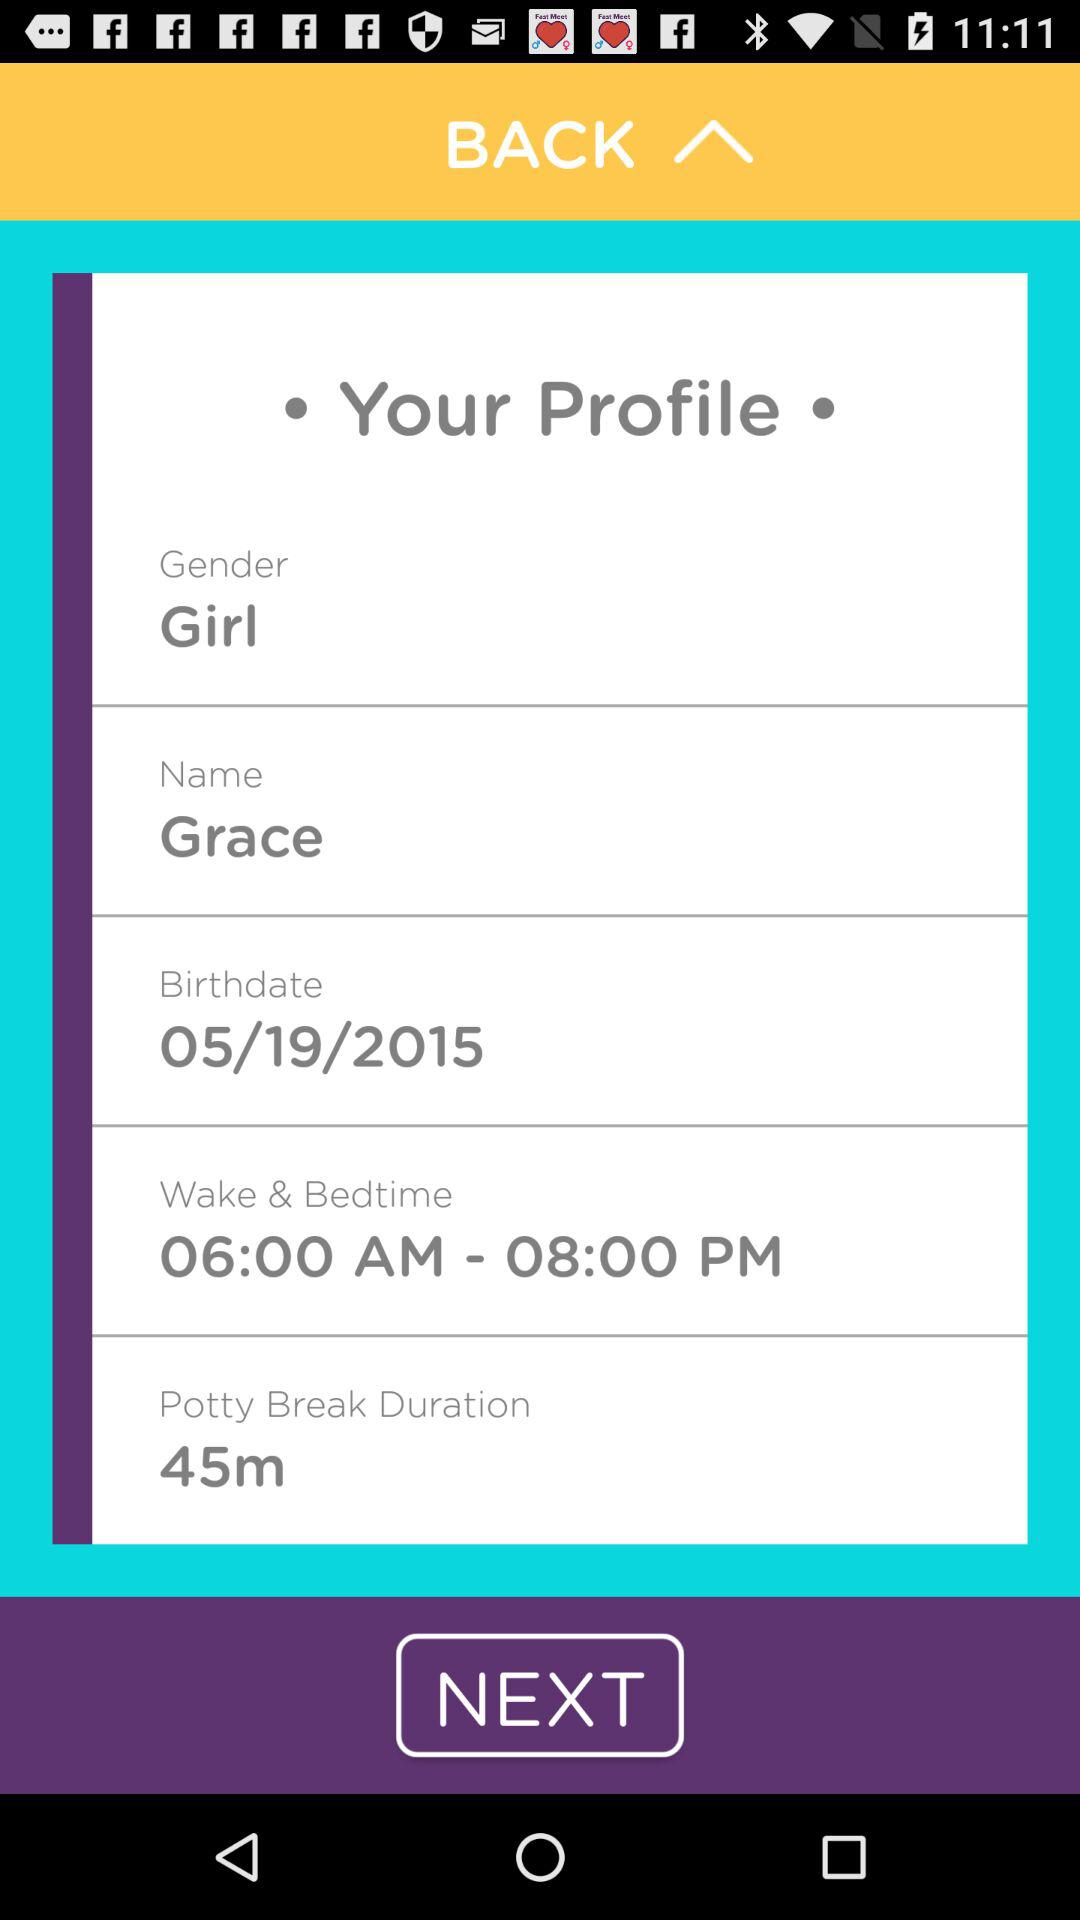What is the birthdate? The birthdate is May 19, 2015. 